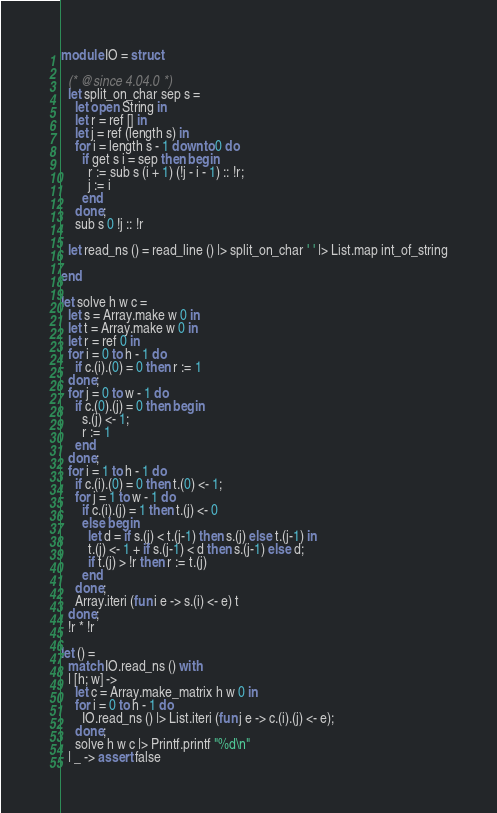Convert code to text. <code><loc_0><loc_0><loc_500><loc_500><_OCaml_>module IO = struct

  (* @since 4.04.0 *)
  let split_on_char sep s =
    let open String in
    let r = ref [] in
    let j = ref (length s) in
    for i = length s - 1 downto 0 do
      if get s i = sep then begin
        r := sub s (i + 1) (!j - i - 1) :: !r;
        j := i
      end
    done;
    sub s 0 !j :: !r

  let read_ns () = read_line () |> split_on_char ' ' |> List.map int_of_string

end

let solve h w c =
  let s = Array.make w 0 in
  let t = Array.make w 0 in
  let r = ref 0 in
  for i = 0 to h - 1 do
    if c.(i).(0) = 0 then r := 1
  done;
  for j = 0 to w - 1 do
    if c.(0).(j) = 0 then begin
      s.(j) <- 1;
      r := 1
    end
  done;
  for i = 1 to h - 1 do
    if c.(i).(0) = 0 then t.(0) <- 1;
    for j = 1 to w - 1 do
      if c.(i).(j) = 1 then t.(j) <- 0
      else begin
        let d = if s.(j) < t.(j-1) then s.(j) else t.(j-1) in
        t.(j) <- 1 + if s.(j-1) < d then s.(j-1) else d;
        if t.(j) > !r then r := t.(j)
      end
    done;
    Array.iteri (fun i e -> s.(i) <- e) t
  done;
  !r * !r

let () =
  match IO.read_ns () with
  | [h; w] ->
    let c = Array.make_matrix h w 0 in
    for i = 0 to h - 1 do
      IO.read_ns () |> List.iteri (fun j e -> c.(i).(j) <- e);
    done;
    solve h w c |> Printf.printf "%d\n"
  | _ -> assert false</code> 